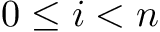<formula> <loc_0><loc_0><loc_500><loc_500>0 \leq i < n</formula> 